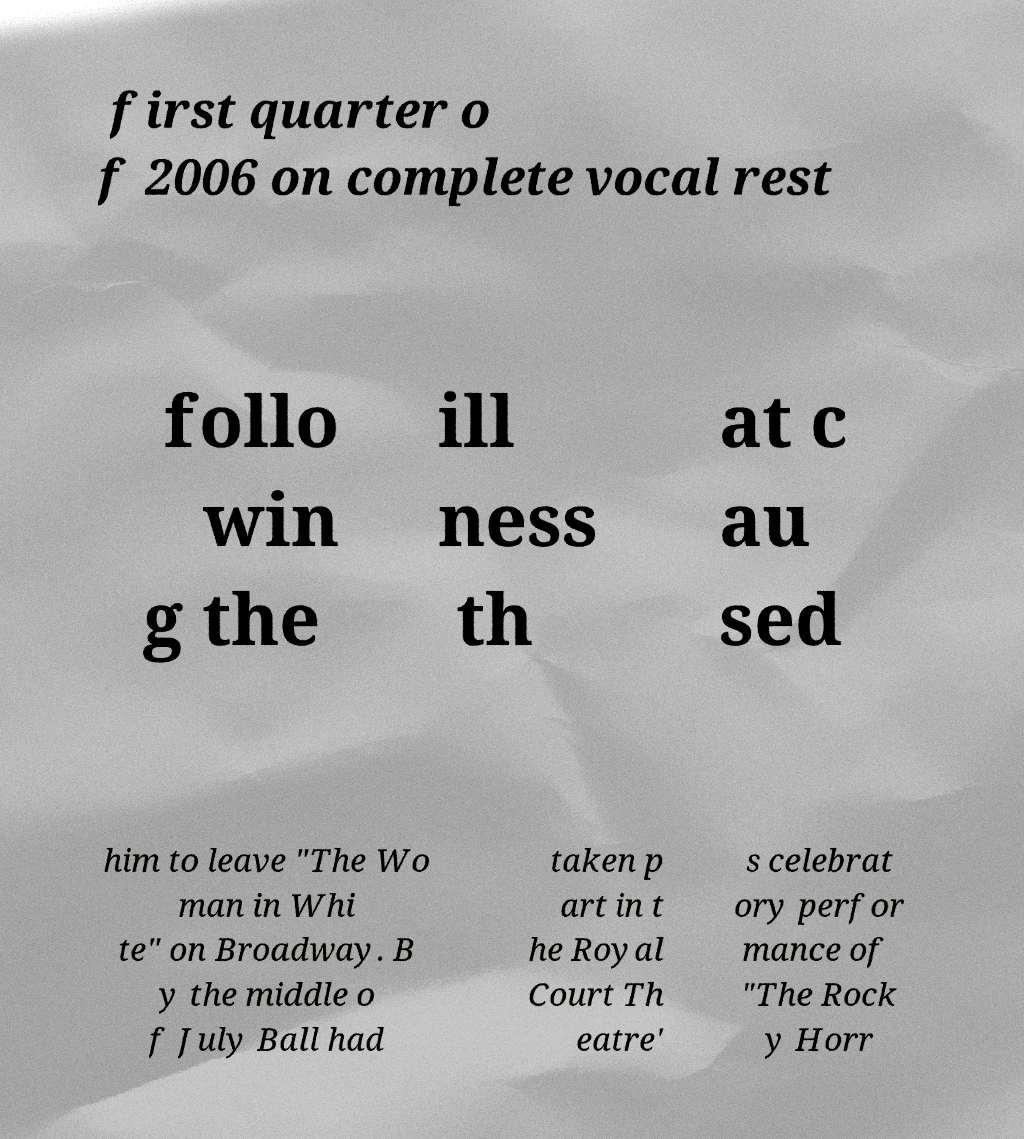Can you accurately transcribe the text from the provided image for me? first quarter o f 2006 on complete vocal rest follo win g the ill ness th at c au sed him to leave "The Wo man in Whi te" on Broadway. B y the middle o f July Ball had taken p art in t he Royal Court Th eatre' s celebrat ory perfor mance of "The Rock y Horr 